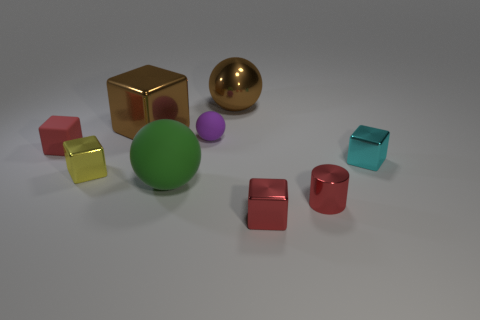What kinds of materials do the objects appear to be made from? The objects seem to be made from different materials, denoted by their surfaces and light reflections. There's a golden sphere and a yellow cube that appear metallic, whereas the other objects have matte finishes suggesting they could be made of plastic or rubber, each contributing to a contrasting texture within the image. Can you tell which object stands out the most? The golden sphere stands out due to its reflective surface and rich color, drawing the eye amidst the other objects which have less shine and more subdued hues. 